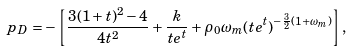Convert formula to latex. <formula><loc_0><loc_0><loc_500><loc_500>p _ { D } = - \left [ \frac { 3 ( 1 + t ) ^ { 2 } - 4 } { 4 t ^ { 2 } } + \frac { k } { t e ^ { t } } + \rho _ { 0 } \omega _ { m } ( t e ^ { t } ) ^ { - \frac { 3 } { 2 } ( 1 + \omega _ { m } ) } \right ] ,</formula> 